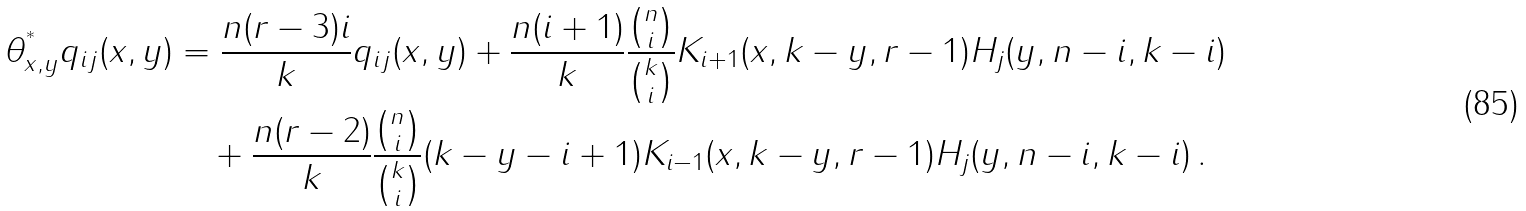Convert formula to latex. <formula><loc_0><loc_0><loc_500><loc_500>\theta ^ { ^ { * } } _ { x , y } q _ { i j } ( x , y ) & = \frac { n ( r - 3 ) i } { k } q _ { i j } ( x , y ) + \frac { n ( i + 1 ) } { k } \frac { \binom { n } { i } } { \binom { k } { i } } K _ { i + 1 } ( x , k - y , r - 1 ) H _ { j } ( y , n - i , k - i ) \\ & \quad + \frac { n ( r - 2 ) } { k } \frac { \binom { n } { i } } { \binom { k } { i } } ( k - y - i + 1 ) K _ { i - 1 } ( x , k - y , r - 1 ) H _ { j } ( y , n - i , k - i ) \, .</formula> 